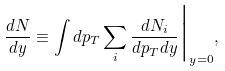Convert formula to latex. <formula><loc_0><loc_0><loc_500><loc_500>\frac { d N } { d y } \equiv \int d p _ { T } \sum _ { i } \frac { d N _ { i } } { d p _ { T } d y } \Big | _ { y = 0 } ,</formula> 